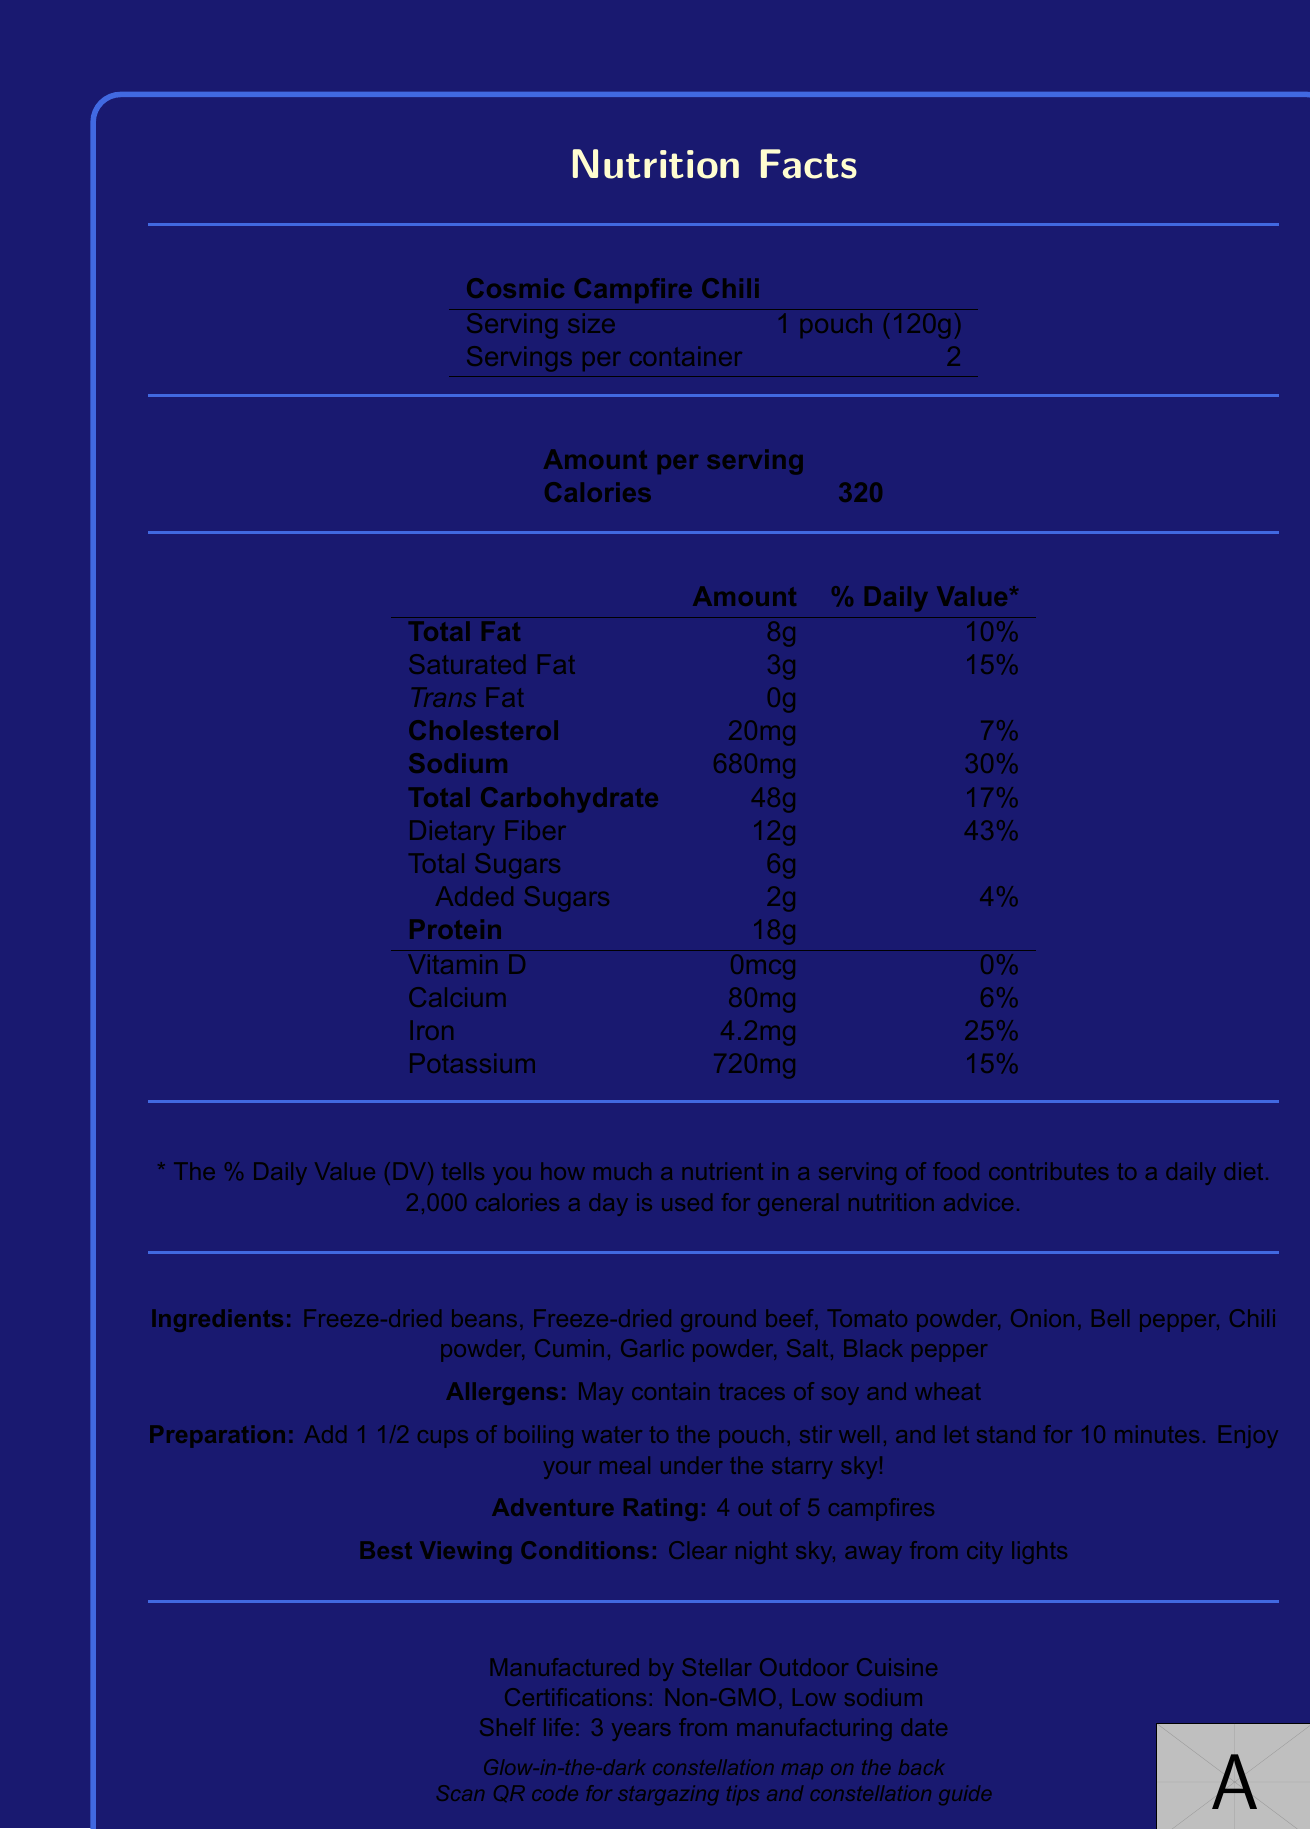What is the serving size of the Cosmic Campfire Chili? The document states that the serving size is "1 pouch (120g)".
Answer: 1 pouch (120g) How many servings are in one container? The document indicates that there are 2 servings per container.
Answer: 2 How much dietary fiber is in one serving? The document shows that each serving contains 12g of dietary fiber.
Answer: 12g What are the allergens listed for the Cosmic Campfire Chili? The document mentions that the product may contain traces of soy and wheat.
Answer: May contain traces of soy and wheat What is the preparation method for the Cosmic Campfire Chili? The preparation instructions in the document specify to add boiling water, stir, and let it stand.
Answer: Add 1 1/2 cups of boiling water to the pouch, stir well, and let stand for 10 minutes. How many calories are in one serving of Cosmic Campfire Chili? A. 320 B. 250 C. 150 D. 400 The document states that one serving contains 320 calories.
Answer: A. 320 What is the daily value percentage of iron in one serving? A. 6% B. 30% C. 25% D. 50% The daily value percentage of iron per serving is listed as 25% in the document.
Answer: C. 25% Does the document mention if the product is non-GMO? The document lists "Non-GMO" as one of the certifications.
Answer: Yes Can this document tell us the price of the Cosmic Campfire Chili? The document does not include any pricing information.
Answer: Not enough information What features are included on the packaging of the Cosmic Campfire Chili? The document lists these features under "packaging features".
Answer: Resealable pouch, Glow-in-the-dark constellation map, QR code linking to stargazing tips and constellation guide Is there any Vitamin D in the Cosmic Campfire Chili? The document shows 0mcg of Vitamin D, which equates to 0% of the daily value.
Answer: No Summarize the main idea of the document. The document gives detailed information about the product's nutritional content, ingredients, potential allergens, how to prepare it, special packaging features, certifications, and best conditions for viewing the stars while using it.
Answer: The document provides the nutritional information, ingredients, allergens, preparation instructions, packaging features, and certifications for the Cosmic Campfire Chili, a freeze-dried camping meal designed with a stargazing theme. 